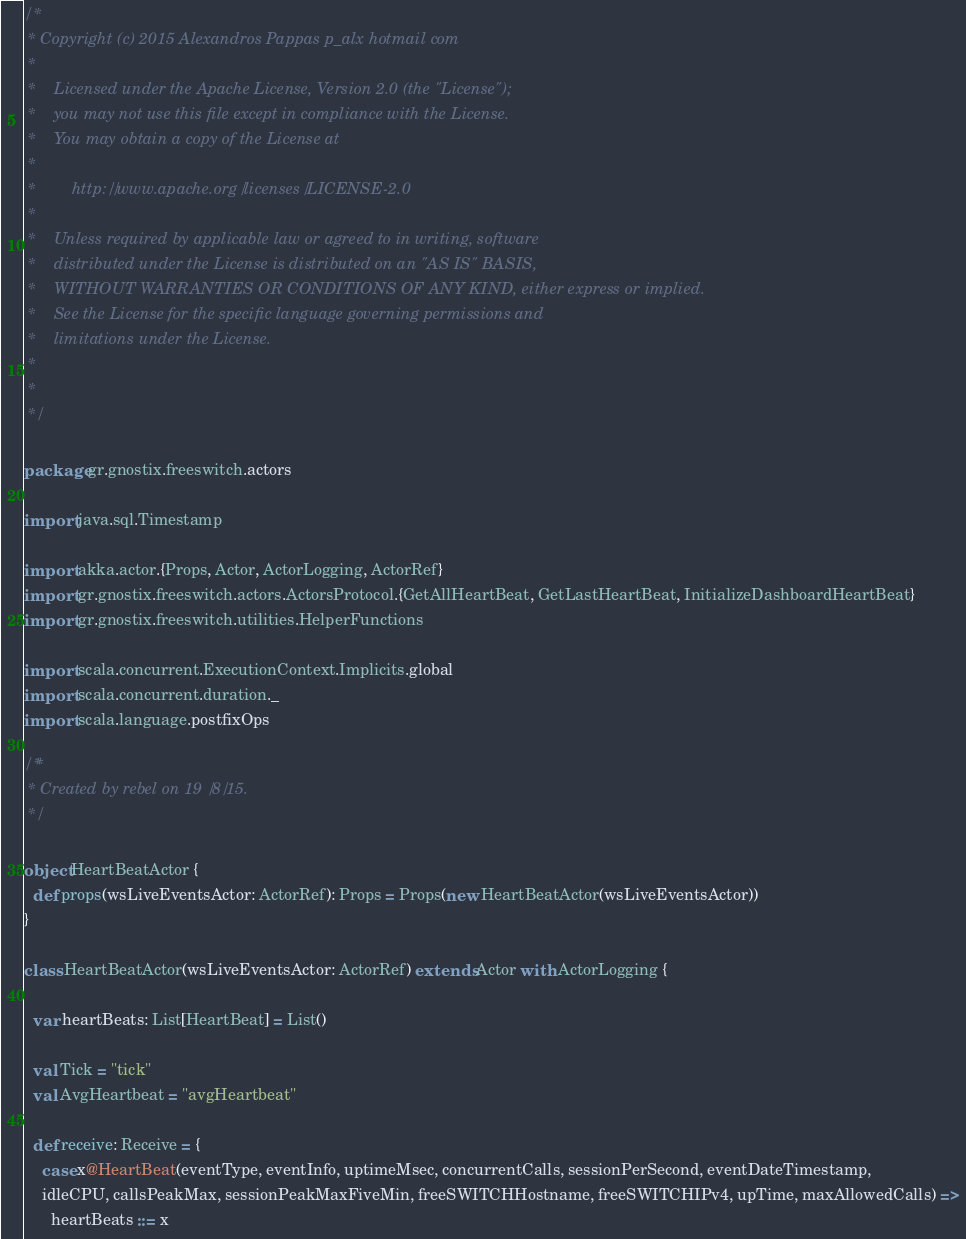Convert code to text. <code><loc_0><loc_0><loc_500><loc_500><_Scala_>/*
 * Copyright (c) 2015 Alexandros Pappas p_alx hotmail com
 *
 *    Licensed under the Apache License, Version 2.0 (the "License");
 *    you may not use this file except in compliance with the License.
 *    You may obtain a copy of the License at
 *
 *        http://www.apache.org/licenses/LICENSE-2.0
 *
 *    Unless required by applicable law or agreed to in writing, software
 *    distributed under the License is distributed on an "AS IS" BASIS,
 *    WITHOUT WARRANTIES OR CONDITIONS OF ANY KIND, either express or implied.
 *    See the License for the specific language governing permissions and
 *    limitations under the License.
 *
 *
 */

package gr.gnostix.freeswitch.actors

import java.sql.Timestamp

import akka.actor.{Props, Actor, ActorLogging, ActorRef}
import gr.gnostix.freeswitch.actors.ActorsProtocol.{GetAllHeartBeat, GetLastHeartBeat, InitializeDashboardHeartBeat}
import gr.gnostix.freeswitch.utilities.HelperFunctions

import scala.concurrent.ExecutionContext.Implicits.global
import scala.concurrent.duration._
import scala.language.postfixOps

/**
 * Created by rebel on 19/8/15.
 */

object HeartBeatActor {
  def props(wsLiveEventsActor: ActorRef): Props = Props(new HeartBeatActor(wsLiveEventsActor))
}

class HeartBeatActor(wsLiveEventsActor: ActorRef) extends Actor with ActorLogging {

  var heartBeats: List[HeartBeat] = List()

  val Tick = "tick"
  val AvgHeartbeat = "avgHeartbeat"

  def receive: Receive = {
    case x@HeartBeat(eventType, eventInfo, uptimeMsec, concurrentCalls, sessionPerSecond, eventDateTimestamp,
    idleCPU, callsPeakMax, sessionPeakMaxFiveMin, freeSWITCHHostname, freeSWITCHIPv4, upTime, maxAllowedCalls) =>
      heartBeats ::= x</code> 